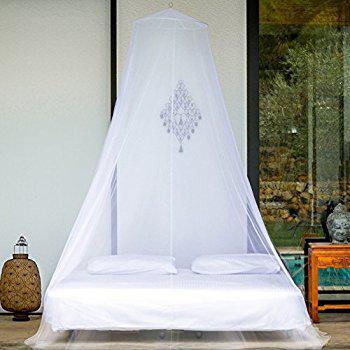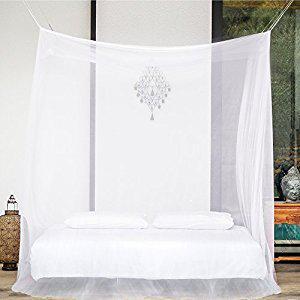The first image is the image on the left, the second image is the image on the right. Given the left and right images, does the statement "In one image, a bed is shown with a lacy, tiered yellow gold bedspread with matching draperies overhead." hold true? Answer yes or no. No. 